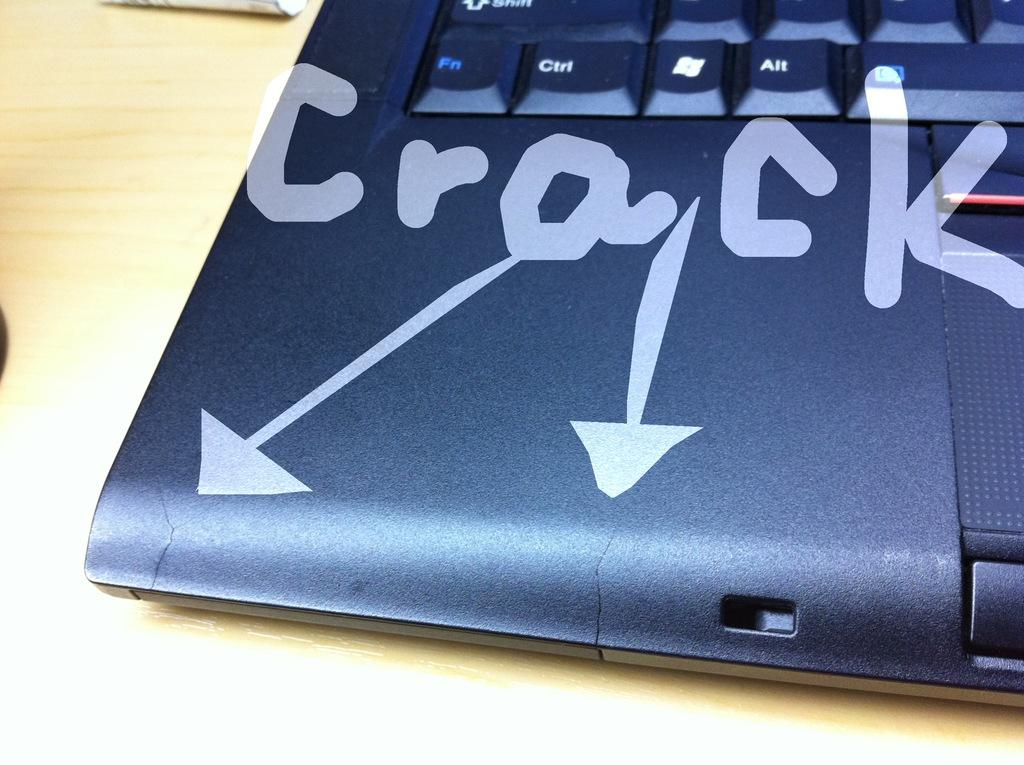<image>
Render a clear and concise summary of the photo. Arrows with "crack" point to issues on the laptop. 